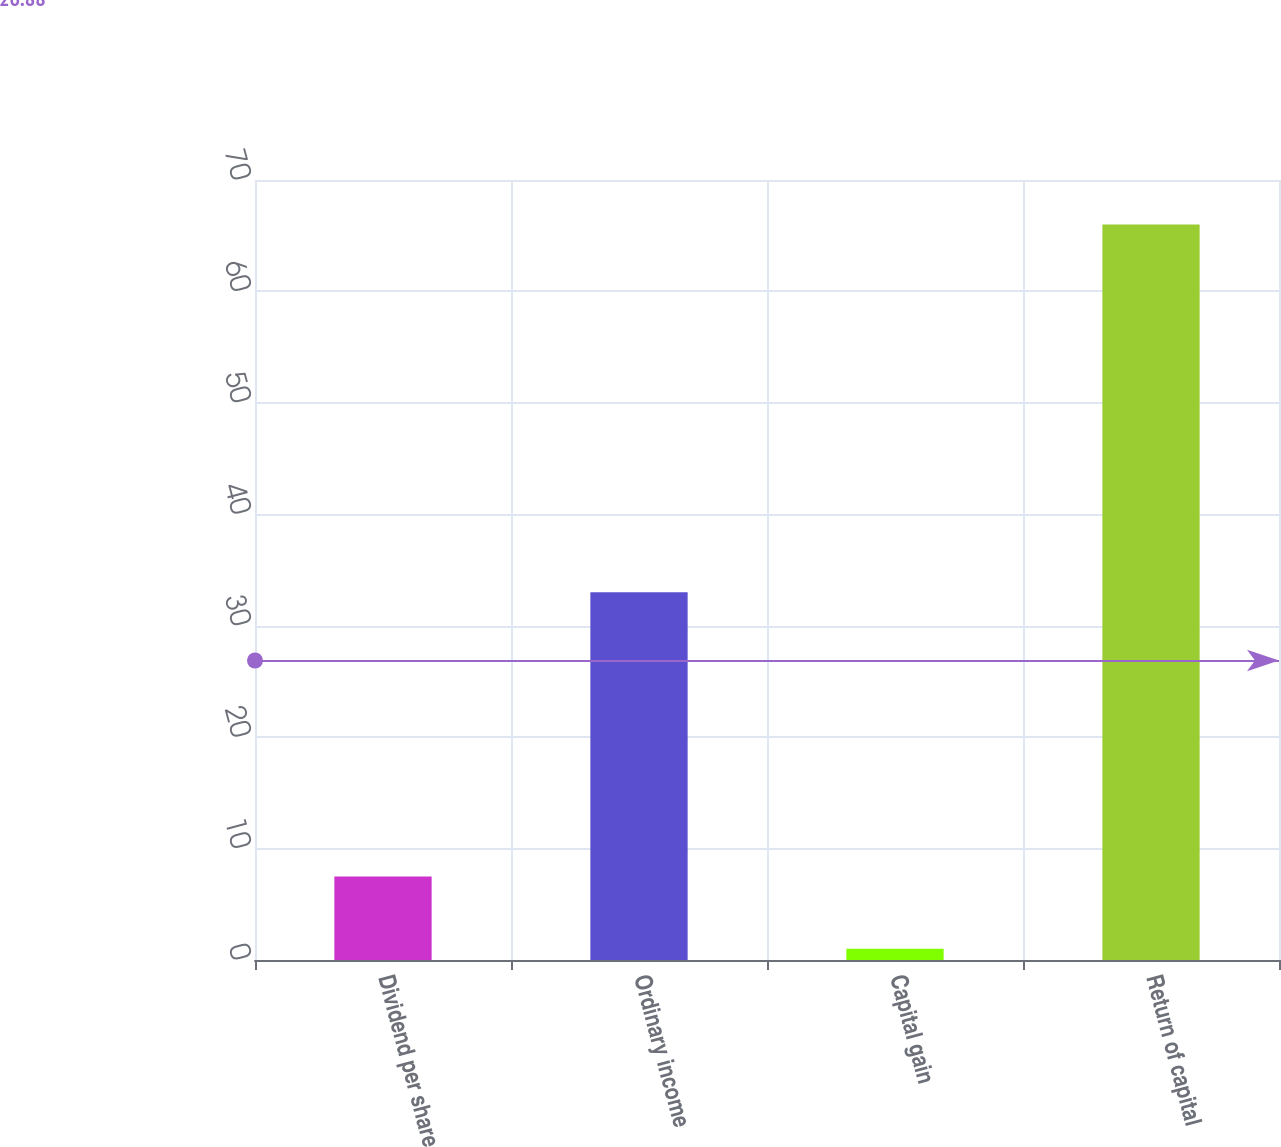<chart> <loc_0><loc_0><loc_500><loc_500><bar_chart><fcel>Dividend per share<fcel>Ordinary income<fcel>Capital gain<fcel>Return of capital<nl><fcel>7.5<fcel>33<fcel>1<fcel>66<nl></chart> 